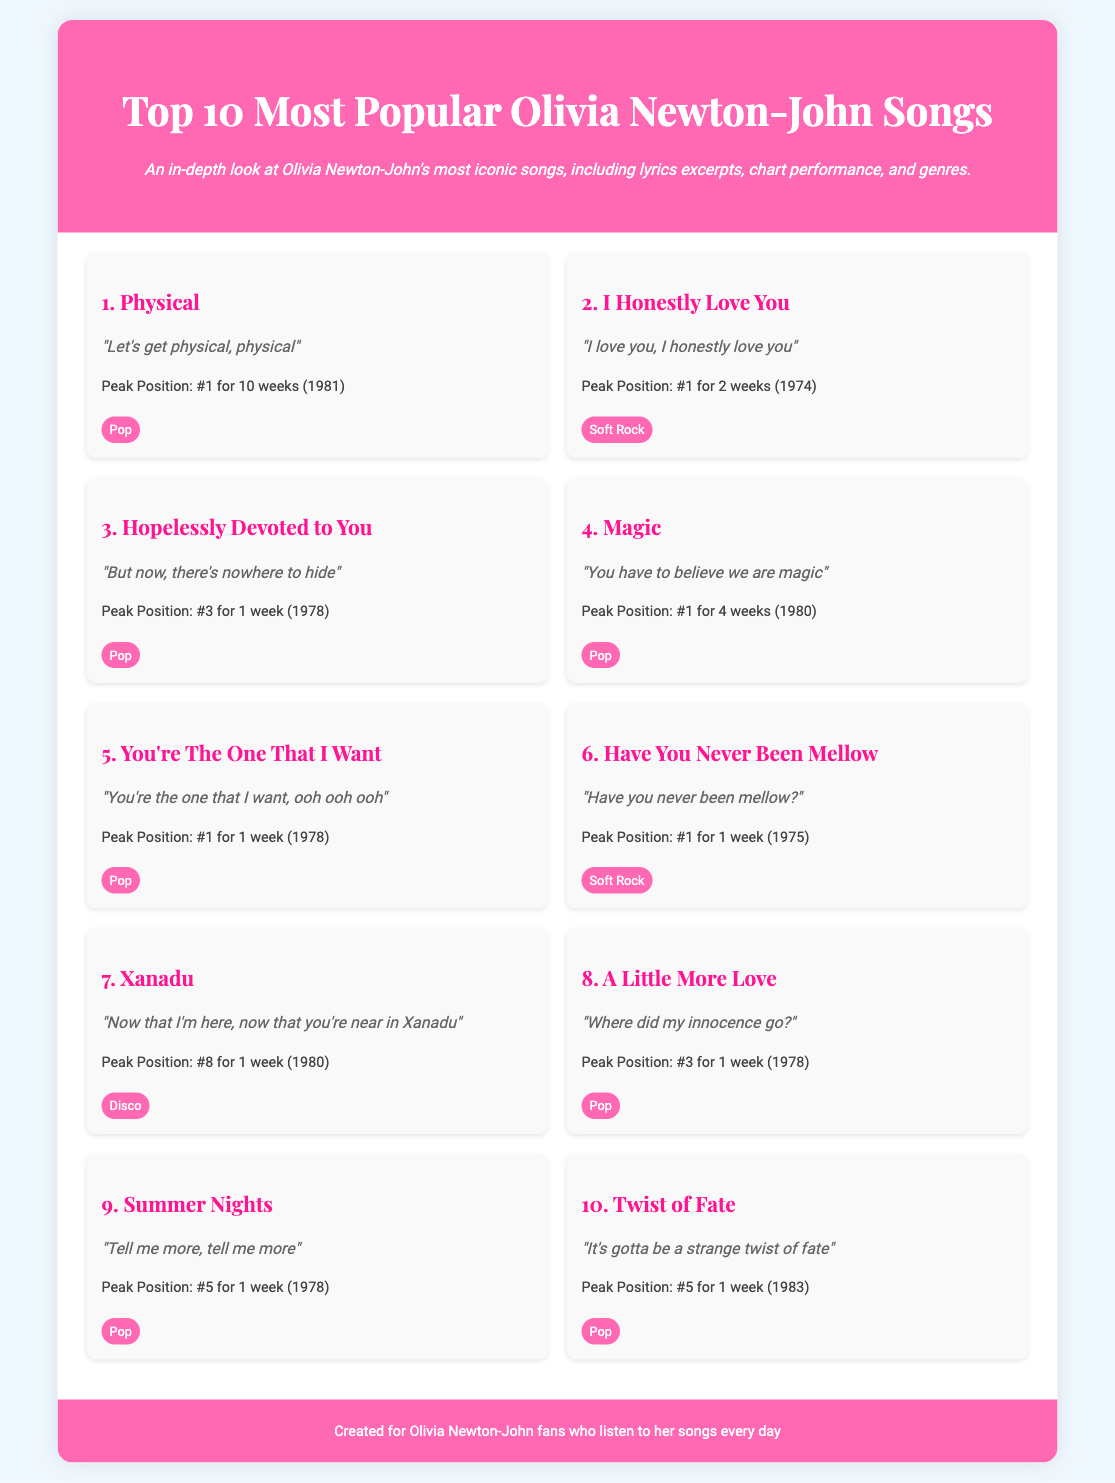What is the title of the most popular song? The title of the most popular song is listed first in the document as "Physical."
Answer: Physical What year did "I Honestly Love You" peak at #1? The document indicates that "I Honestly Love You" reached its peak position in 1974.
Answer: 1974 How many weeks did "Physical" stay at #1? The document notes that "Physical" was at #1 for 10 weeks.
Answer: 10 weeks What is the genre of "Xanadu"? The genre of "Xanadu" is specified in the document as Disco.
Answer: Disco Which song has the peak position of #8? The song that peaked at #8 is mentioned as "Xanadu."
Answer: Xanadu Which two songs both reached the #1 position in the same year, 1978? By analyzing the chart information, "You're The One That I Want" and "Hopelessly Devoted to You" both peaked at #1 in 1978.
Answer: You're The One That I Want and Hopelessly Devoted to You What song contains the lyrics "Let's get physical, physical"? This specific lyric is from the song "Physical," which is also the most popular song in the list.
Answer: Physical What can be inferred about the popularity of Olivia Newton-John’s songs in the 1970s compared to the 1980s? The document shows that a significant number of songs peaked in the 1970s, indicating a strong popularity during that time compared to only one song listed from the 1980s that peaked at #1.
Answer: Stronger popularity in the 1970s How many songs in the list fall under the genre of Pop? By reviewing the genres of the songs, there are 7 songs that fall under the genre of Pop.
Answer: 7 songs 